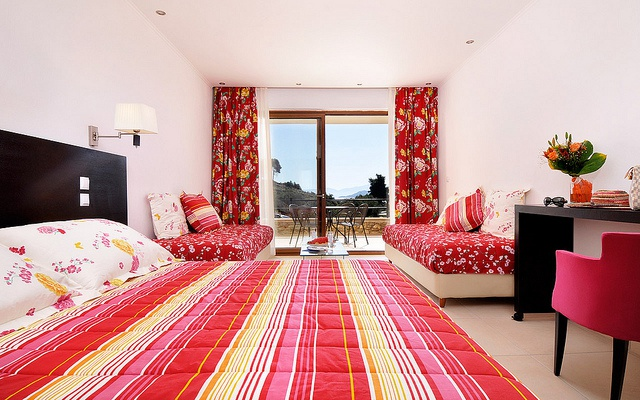Describe the objects in this image and their specific colors. I can see bed in lightgray, white, red, salmon, and lightpink tones, bed in lightgray, lightpink, brown, and tan tones, couch in lightgray, lightpink, brown, and tan tones, chair in lightgray, maroon, brown, and black tones, and bed in lightgray, brown, and lightpink tones in this image. 